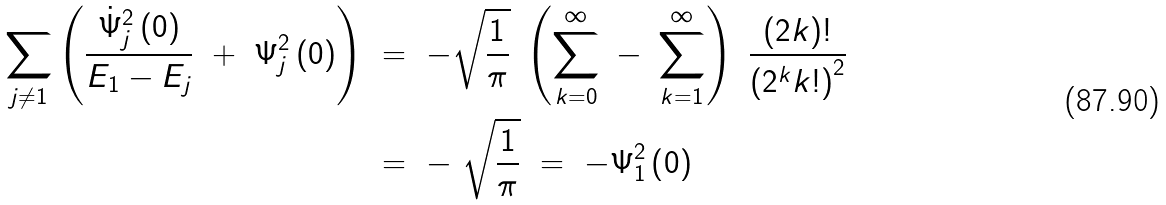Convert formula to latex. <formula><loc_0><loc_0><loc_500><loc_500>\sum _ { j \ne 1 } \left ( \frac { { \dot { \Psi } } _ { j } ^ { 2 } \left ( 0 \right ) } { E _ { 1 } - E _ { j } } \ + \ \Psi _ { j } ^ { 2 } \left ( 0 \right ) \right ) \ & = \ - \sqrt { \frac { 1 } { \pi } } \ \left ( \sum _ { k = 0 } ^ { \infty } \ - \ \sum _ { k = 1 } ^ { \infty } \right ) \ \frac { \left ( 2 k \right ) ! } { \left ( 2 ^ { k } k ! \right ) ^ { 2 } } \\ \ & = \ - \ \sqrt { \frac { 1 } { \pi } } \ = \ - \Psi _ { 1 } ^ { 2 } \left ( 0 \right )</formula> 